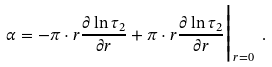<formula> <loc_0><loc_0><loc_500><loc_500>\alpha = - \pi \cdot r \frac { \partial \ln \tau _ { 2 } } { \partial r } + \pi \cdot r \frac { \partial \ln \tau _ { 2 } } { \partial r } \Big | _ { r = 0 } \ .</formula> 